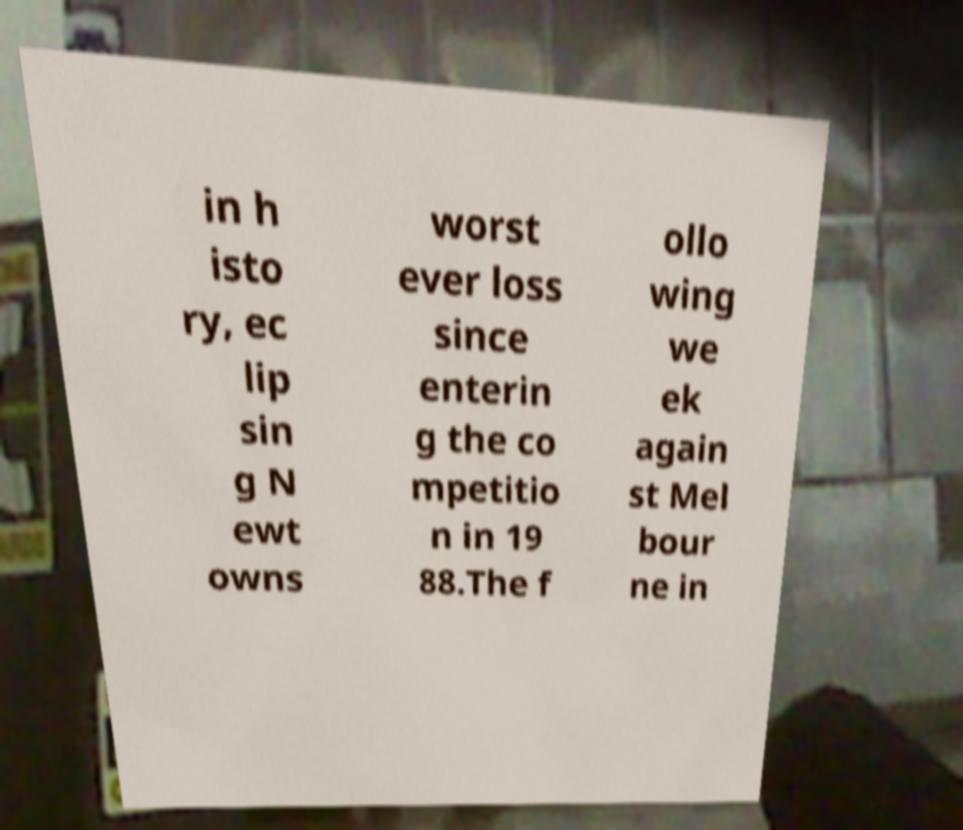Can you read and provide the text displayed in the image?This photo seems to have some interesting text. Can you extract and type it out for me? in h isto ry, ec lip sin g N ewt owns worst ever loss since enterin g the co mpetitio n in 19 88.The f ollo wing we ek again st Mel bour ne in 